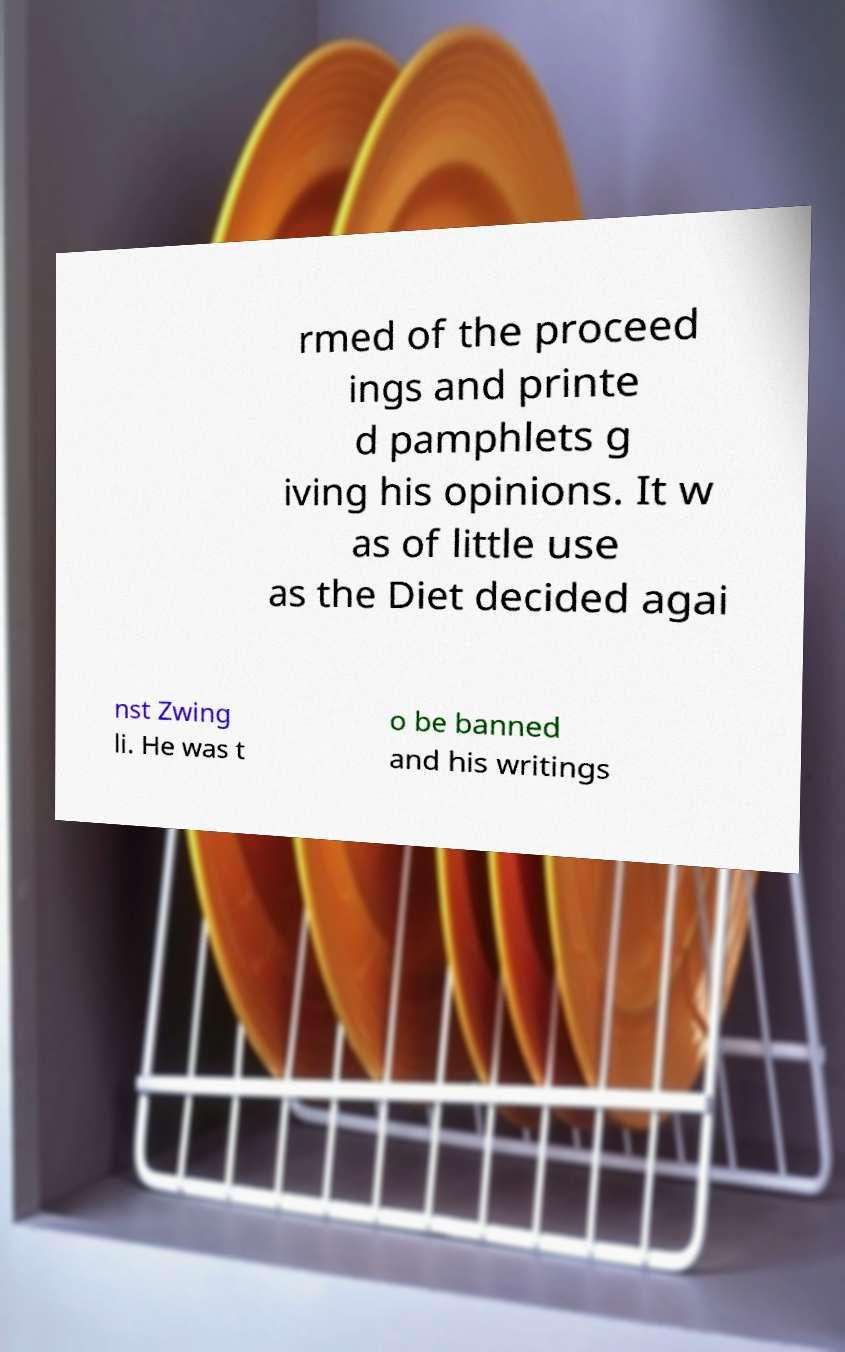I need the written content from this picture converted into text. Can you do that? rmed of the proceed ings and printe d pamphlets g iving his opinions. It w as of little use as the Diet decided agai nst Zwing li. He was t o be banned and his writings 